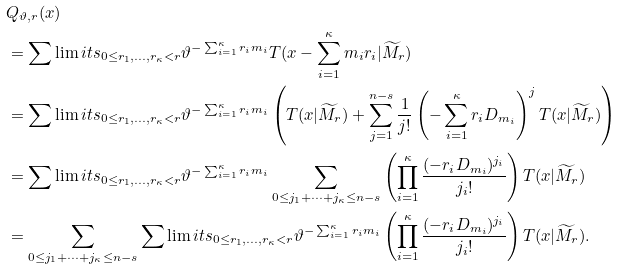<formula> <loc_0><loc_0><loc_500><loc_500>& Q _ { \vartheta , r } ( x ) \\ & = \sum \lim i t s _ { 0 \leq r _ { 1 } , \dots , r _ { \kappa } < r } { \vartheta } ^ { - \sum _ { i = 1 } ^ { \kappa } r _ { i } m _ { i } } T ( x - \sum _ { i = 1 } ^ { \kappa } m _ { i } r _ { i } | \widetilde { M } _ { r } ) \\ & = \sum \lim i t s _ { 0 \leq r _ { 1 } , \dots , r _ { \kappa } < r } { \vartheta } ^ { - \sum _ { i = 1 } ^ { \kappa } r _ { i } m _ { i } } \left ( T ( x | \widetilde { M } _ { r } ) + \sum _ { j = 1 } ^ { n - s } \frac { 1 } { j ! } \left ( - \sum _ { i = 1 } ^ { \kappa } r _ { i } D _ { m _ { i } } \right ) ^ { j } T ( x | \widetilde { M } _ { r } ) \right ) \\ & = \sum \lim i t s _ { 0 \leq r _ { 1 } , \dots , r _ { \kappa } < r } { \vartheta } ^ { - \sum _ { i = 1 } ^ { \kappa } r _ { i } m _ { i } } \sum _ { 0 \leq j _ { 1 } + \cdots + j _ { \kappa } \leq n - s } \left ( \prod _ { i = 1 } ^ { \kappa } \frac { ( - r _ { i } D _ { m _ { i } } ) ^ { j _ { i } } } { j _ { i } ! } \right ) T ( x | \widetilde { M } _ { r } ) \\ & = \sum _ { 0 \leq j _ { 1 } + \cdots + j _ { \kappa } \leq n - s } \sum \lim i t s _ { 0 \leq r _ { 1 } , \dots , r _ { \kappa } < r } { \vartheta } ^ { - \sum _ { i = 1 } ^ { \kappa } r _ { i } m _ { i } } \left ( \prod _ { i = 1 } ^ { \kappa } \frac { ( - r _ { i } D _ { m _ { i } } ) ^ { j _ { i } } } { j _ { i } ! } \right ) T ( x | \widetilde { M } _ { r } ) .</formula> 